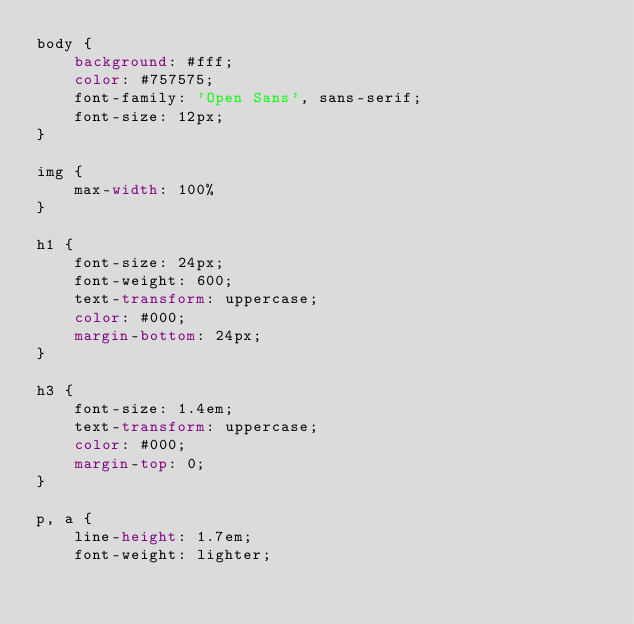Convert code to text. <code><loc_0><loc_0><loc_500><loc_500><_CSS_>body {
    background: #fff;
    color: #757575;
    font-family: 'Open Sans', sans-serif;
    font-size: 12px;
}

img {
    max-width: 100%
}

h1 {
    font-size: 24px;
    font-weight: 600;
    text-transform: uppercase;
    color: #000;
    margin-bottom: 24px;
}

h3 {
    font-size: 1.4em;
    text-transform: uppercase;
    color: #000;
    margin-top: 0;
}

p, a {
    line-height: 1.7em;
    font-weight: lighter;</code> 